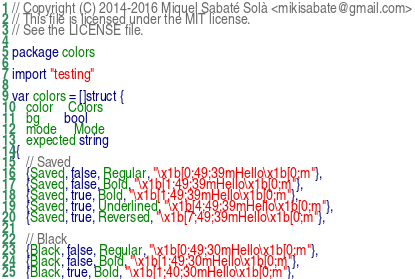Convert code to text. <code><loc_0><loc_0><loc_500><loc_500><_Go_>// Copyright (C) 2014-2016 Miquel Sabaté Solà <mikisabate@gmail.com>
// This file is licensed under the MIT license.
// See the LICENSE file.

package colors

import "testing"

var colors = []struct {
	color    Colors
	bg       bool
	mode     Mode
	expected string
}{
	// Saved
	{Saved, false, Regular, "\x1b[0;49;39mHello\x1b[0;m"},
	{Saved, false, Bold, "\x1b[1;49;39mHello\x1b[0;m"},
	{Saved, true, Bold, "\x1b[1;49;39mHello\x1b[0;m"},
	{Saved, true, Underlined, "\x1b[4;49;39mHello\x1b[0;m"},
	{Saved, true, Reversed, "\x1b[7;49;39mHello\x1b[0;m"},

	// Black
	{Black, false, Regular, "\x1b[0;49;30mHello\x1b[0;m"},
	{Black, false, Bold, "\x1b[1;49;30mHello\x1b[0;m"},
	{Black, true, Bold, "\x1b[1;40;30mHello\x1b[0;m"},</code> 